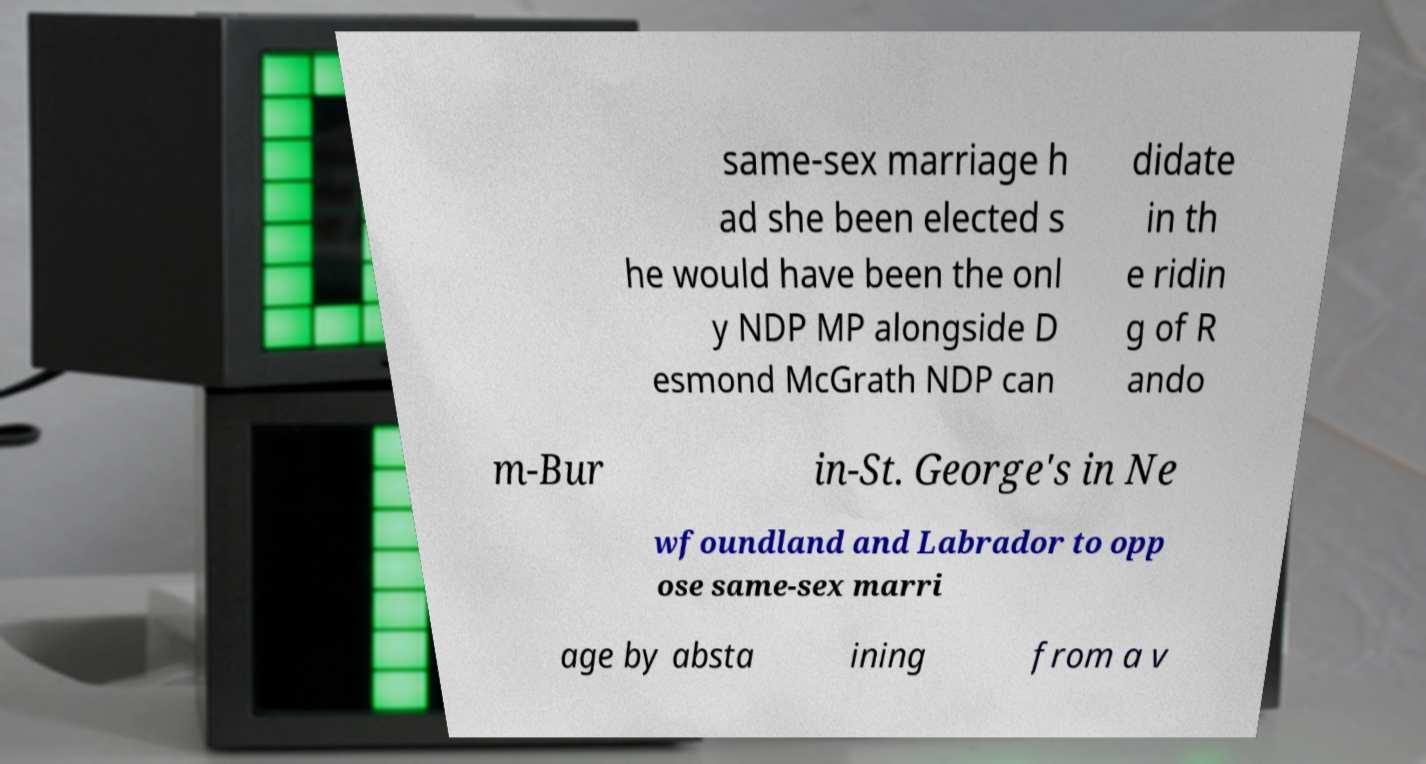Could you assist in decoding the text presented in this image and type it out clearly? same-sex marriage h ad she been elected s he would have been the onl y NDP MP alongside D esmond McGrath NDP can didate in th e ridin g of R ando m-Bur in-St. George's in Ne wfoundland and Labrador to opp ose same-sex marri age by absta ining from a v 